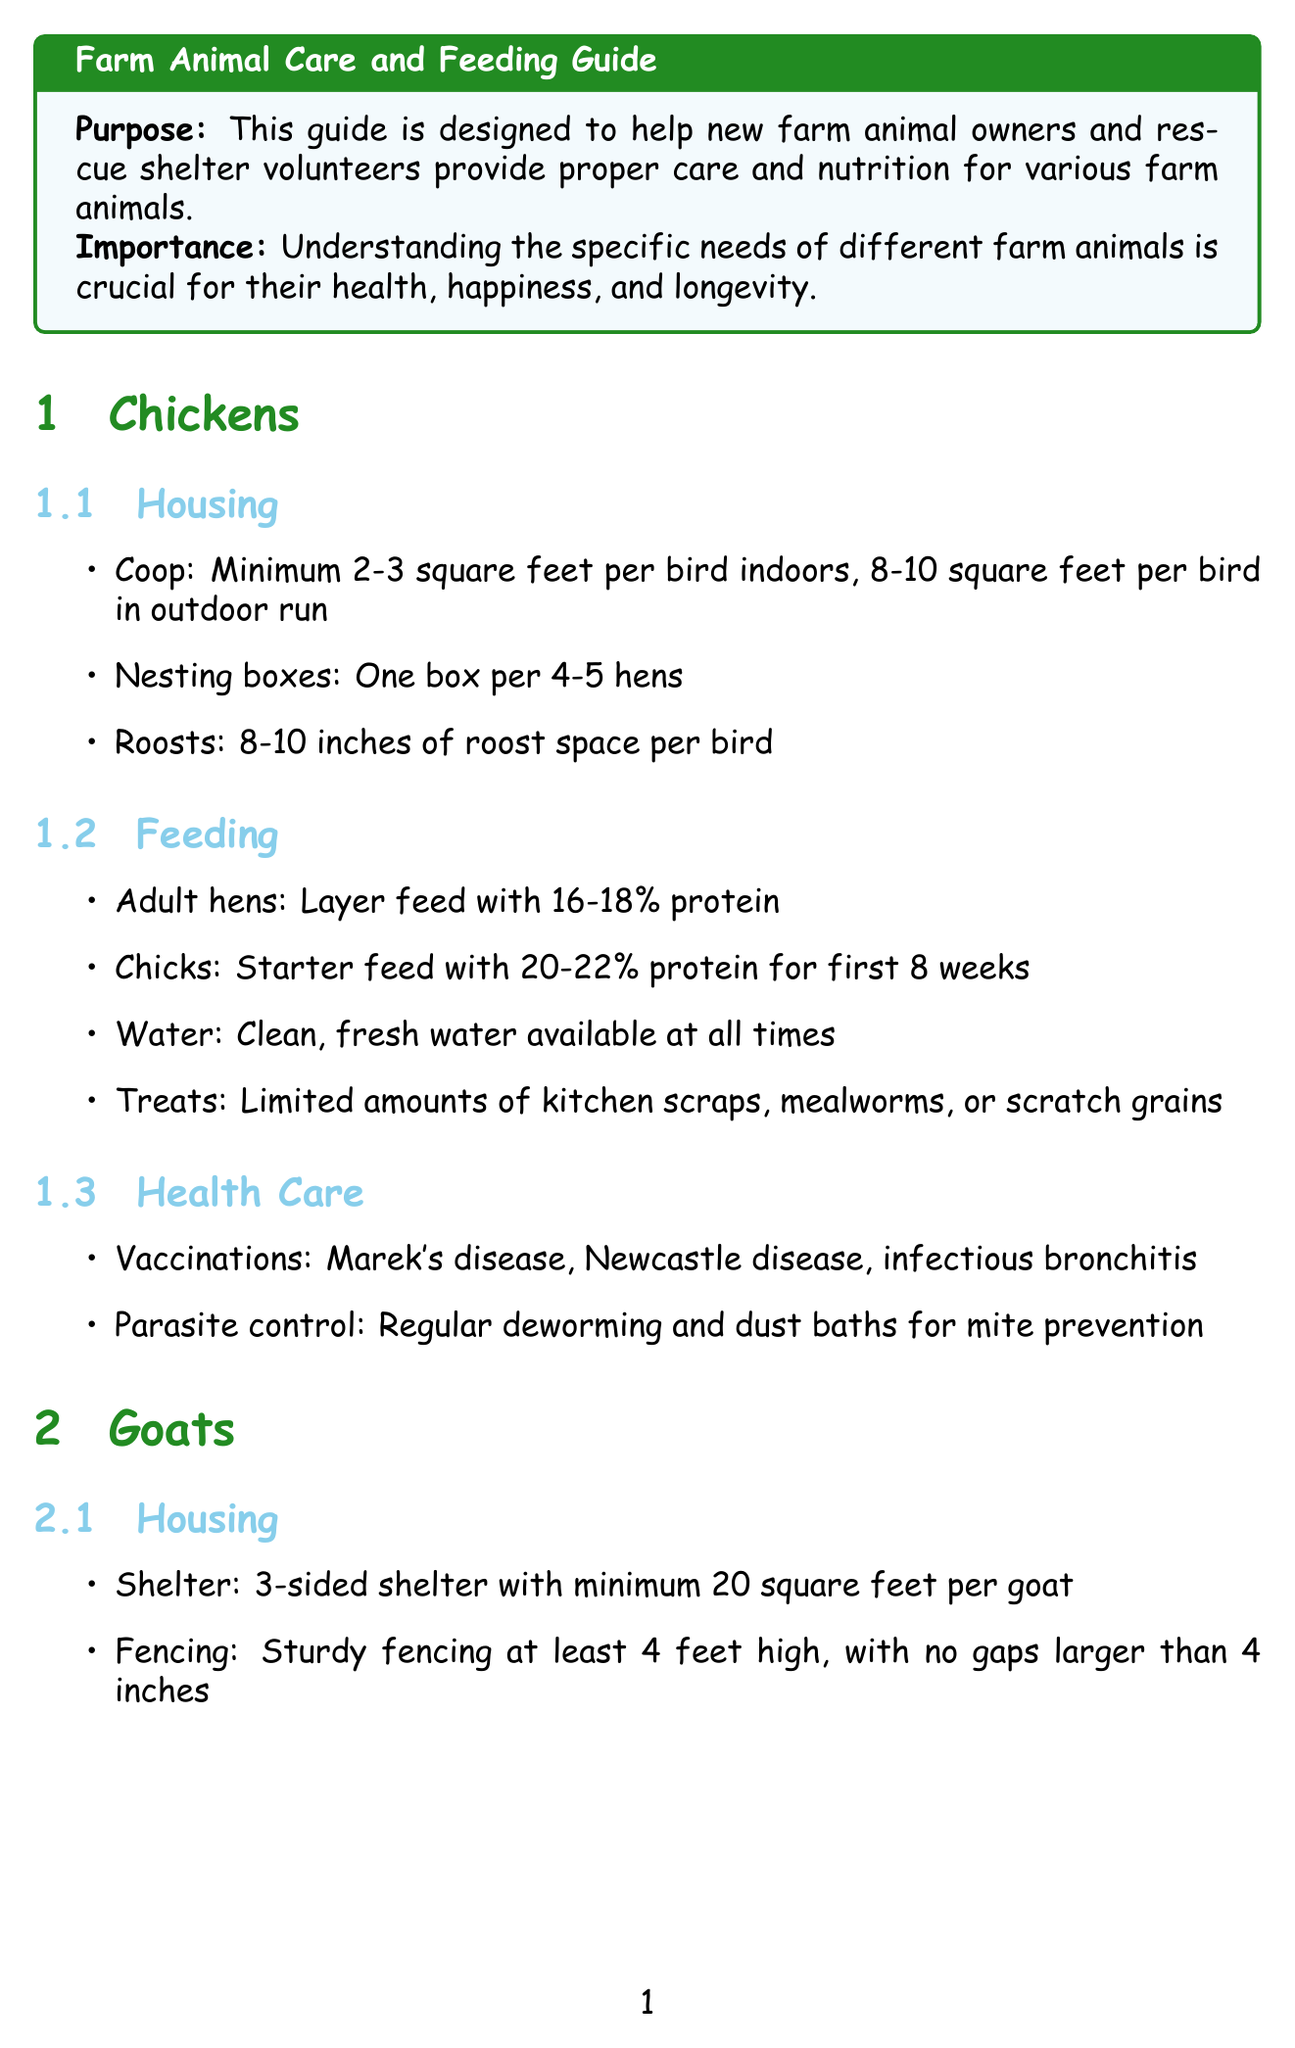What is the recommended protein percentage for adult hens? The document specifies the feeding requirements for adult hens, which is a layer feed with 16-18% protein.
Answer: 16-18% What is the minimum square footage required per goat in their shelter? The housing specifications indicate that a goat requires a minimum of 20 square feet in their shelter.
Answer: 20 square feet How often should pigs get their hooves trimmed? The document states that pigs' hooves should be trimmed as needed, usually every 6-12 months.
Answer: Every 6-12 months What type of fencing is recommended for sheep? The housing section for sheep mentions using woven wire fencing at least 4 feet high.
Answer: Woven wire fencing What is included in the emergency first aid kit? The document lists specific items that should be included in the first aid kit, such as gauze bandages and antiseptic solution.
Answer: Gauze bandages How often should goats be vaccinated for CDT? The health care section for goats indicates that CDT vaccinations should be administered annually.
Answer: Annually What is the purpose of the guide? The introduction of the document outlines the purpose of the guide to help new farm animal owners and rescue shelter volunteers provide proper care and nutrition.
Answer: To help new farm animal owners and rescue shelter volunteers What should be observed daily in farm animals? The general care tips highlight the importance of observing animals daily for signs of illness or injury.
Answer: Signs of illness or injury What type of mineral supplement is recommended for goats? The feeding section for goats advises the use of a free-choice goat-specific mineral supplement.
Answer: Goat-specific mineral supplement 